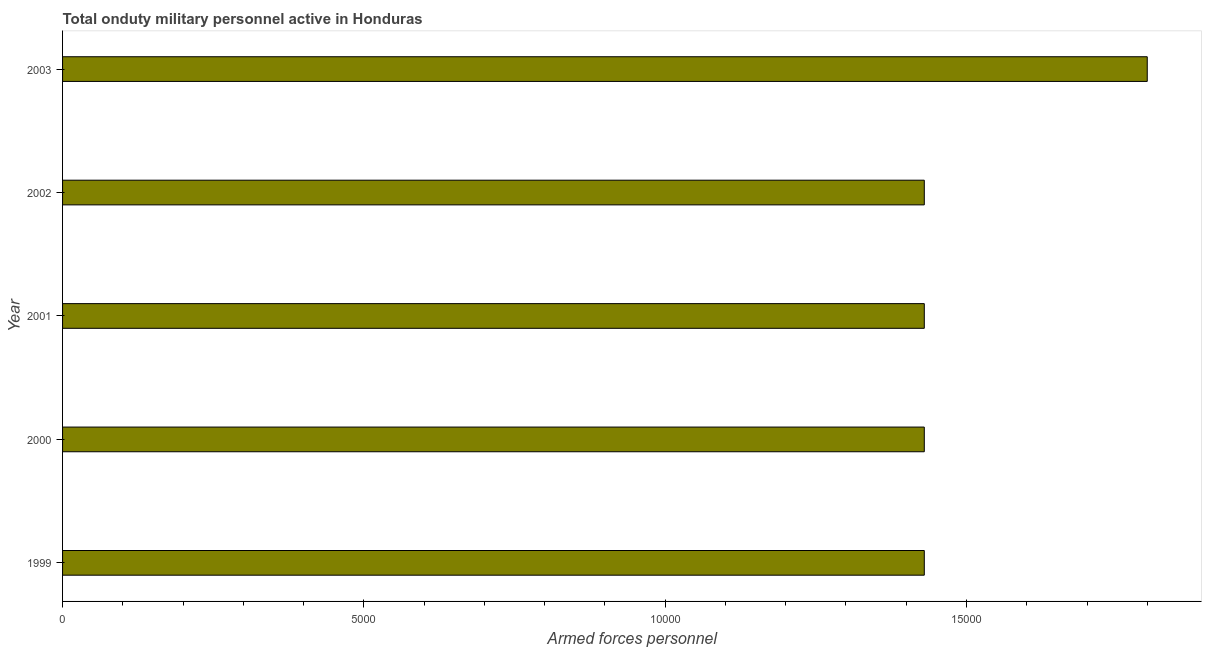Does the graph contain any zero values?
Keep it short and to the point. No. What is the title of the graph?
Your answer should be very brief. Total onduty military personnel active in Honduras. What is the label or title of the X-axis?
Offer a terse response. Armed forces personnel. What is the label or title of the Y-axis?
Provide a short and direct response. Year. What is the number of armed forces personnel in 1999?
Give a very brief answer. 1.43e+04. Across all years, what is the maximum number of armed forces personnel?
Your answer should be very brief. 1.80e+04. Across all years, what is the minimum number of armed forces personnel?
Provide a short and direct response. 1.43e+04. What is the sum of the number of armed forces personnel?
Your answer should be compact. 7.52e+04. What is the difference between the number of armed forces personnel in 2001 and 2003?
Give a very brief answer. -3700. What is the average number of armed forces personnel per year?
Provide a succinct answer. 1.50e+04. What is the median number of armed forces personnel?
Make the answer very short. 1.43e+04. Do a majority of the years between 2002 and 2003 (inclusive) have number of armed forces personnel greater than 9000 ?
Your answer should be very brief. Yes. What is the ratio of the number of armed forces personnel in 2000 to that in 2003?
Offer a terse response. 0.79. Is the number of armed forces personnel in 2000 less than that in 2003?
Keep it short and to the point. Yes. Is the difference between the number of armed forces personnel in 2000 and 2002 greater than the difference between any two years?
Provide a short and direct response. No. What is the difference between the highest and the second highest number of armed forces personnel?
Provide a short and direct response. 3700. What is the difference between the highest and the lowest number of armed forces personnel?
Provide a short and direct response. 3700. In how many years, is the number of armed forces personnel greater than the average number of armed forces personnel taken over all years?
Your answer should be very brief. 1. How many bars are there?
Make the answer very short. 5. Are all the bars in the graph horizontal?
Offer a terse response. Yes. What is the difference between two consecutive major ticks on the X-axis?
Make the answer very short. 5000. Are the values on the major ticks of X-axis written in scientific E-notation?
Offer a very short reply. No. What is the Armed forces personnel in 1999?
Your answer should be compact. 1.43e+04. What is the Armed forces personnel in 2000?
Provide a short and direct response. 1.43e+04. What is the Armed forces personnel of 2001?
Ensure brevity in your answer.  1.43e+04. What is the Armed forces personnel in 2002?
Offer a terse response. 1.43e+04. What is the Armed forces personnel of 2003?
Your answer should be very brief. 1.80e+04. What is the difference between the Armed forces personnel in 1999 and 2001?
Provide a short and direct response. 0. What is the difference between the Armed forces personnel in 1999 and 2003?
Provide a short and direct response. -3700. What is the difference between the Armed forces personnel in 2000 and 2001?
Provide a succinct answer. 0. What is the difference between the Armed forces personnel in 2000 and 2003?
Keep it short and to the point. -3700. What is the difference between the Armed forces personnel in 2001 and 2002?
Offer a very short reply. 0. What is the difference between the Armed forces personnel in 2001 and 2003?
Make the answer very short. -3700. What is the difference between the Armed forces personnel in 2002 and 2003?
Make the answer very short. -3700. What is the ratio of the Armed forces personnel in 1999 to that in 2002?
Provide a succinct answer. 1. What is the ratio of the Armed forces personnel in 1999 to that in 2003?
Your answer should be very brief. 0.79. What is the ratio of the Armed forces personnel in 2000 to that in 2001?
Your response must be concise. 1. What is the ratio of the Armed forces personnel in 2000 to that in 2003?
Your response must be concise. 0.79. What is the ratio of the Armed forces personnel in 2001 to that in 2002?
Your answer should be compact. 1. What is the ratio of the Armed forces personnel in 2001 to that in 2003?
Keep it short and to the point. 0.79. What is the ratio of the Armed forces personnel in 2002 to that in 2003?
Keep it short and to the point. 0.79. 